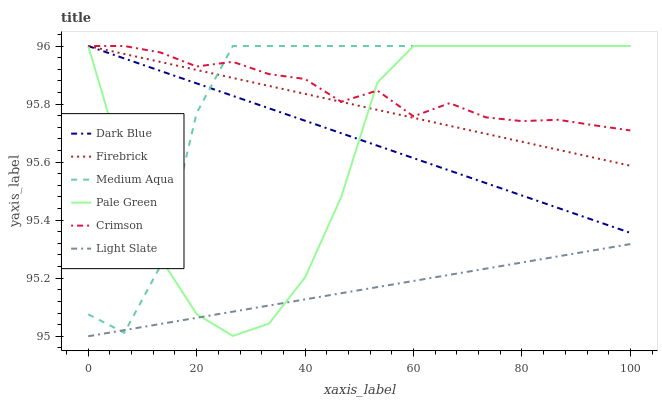Does Light Slate have the minimum area under the curve?
Answer yes or no. Yes. Does Crimson have the maximum area under the curve?
Answer yes or no. Yes. Does Firebrick have the minimum area under the curve?
Answer yes or no. No. Does Firebrick have the maximum area under the curve?
Answer yes or no. No. Is Dark Blue the smoothest?
Answer yes or no. Yes. Is Pale Green the roughest?
Answer yes or no. Yes. Is Firebrick the smoothest?
Answer yes or no. No. Is Firebrick the roughest?
Answer yes or no. No. Does Light Slate have the lowest value?
Answer yes or no. Yes. Does Firebrick have the lowest value?
Answer yes or no. No. Does Crimson have the highest value?
Answer yes or no. Yes. Is Light Slate less than Dark Blue?
Answer yes or no. Yes. Is Firebrick greater than Light Slate?
Answer yes or no. Yes. Does Dark Blue intersect Firebrick?
Answer yes or no. Yes. Is Dark Blue less than Firebrick?
Answer yes or no. No. Is Dark Blue greater than Firebrick?
Answer yes or no. No. Does Light Slate intersect Dark Blue?
Answer yes or no. No. 